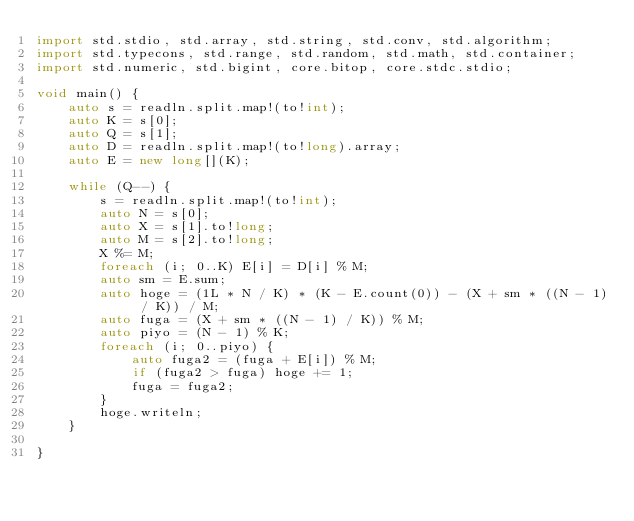<code> <loc_0><loc_0><loc_500><loc_500><_D_>import std.stdio, std.array, std.string, std.conv, std.algorithm;
import std.typecons, std.range, std.random, std.math, std.container;
import std.numeric, std.bigint, core.bitop, core.stdc.stdio;

void main() {
    auto s = readln.split.map!(to!int);
    auto K = s[0];
    auto Q = s[1];
    auto D = readln.split.map!(to!long).array;
    auto E = new long[](K);

    while (Q--) {
        s = readln.split.map!(to!int);
        auto N = s[0];
        auto X = s[1].to!long;
        auto M = s[2].to!long;
        X %= M;
        foreach (i; 0..K) E[i] = D[i] % M;
        auto sm = E.sum;
        auto hoge = (1L * N / K) * (K - E.count(0)) - (X + sm * ((N - 1) / K)) / M;
        auto fuga = (X + sm * ((N - 1) / K)) % M;
        auto piyo = (N - 1) % K;
        foreach (i; 0..piyo) {
            auto fuga2 = (fuga + E[i]) % M;
            if (fuga2 > fuga) hoge += 1;
            fuga = fuga2;
        }
        hoge.writeln;
    }

}</code> 